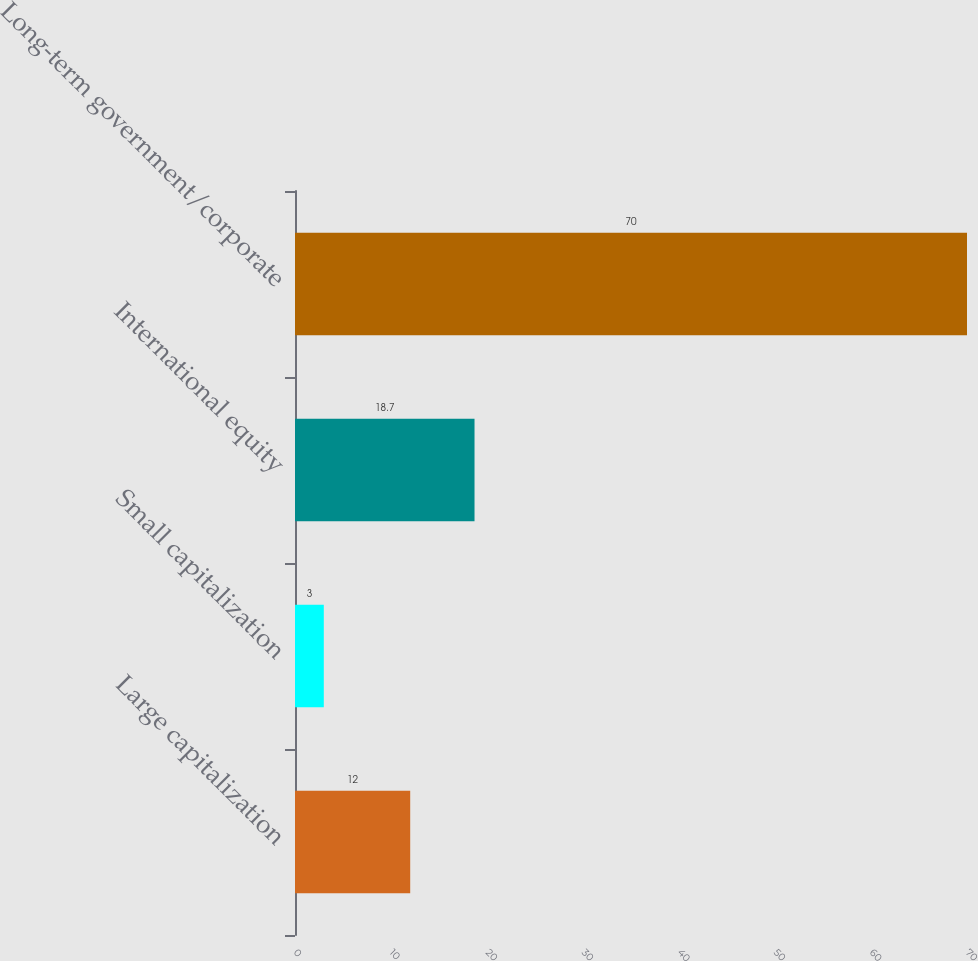Convert chart to OTSL. <chart><loc_0><loc_0><loc_500><loc_500><bar_chart><fcel>Large capitalization<fcel>Small capitalization<fcel>International equity<fcel>Long-term government/corporate<nl><fcel>12<fcel>3<fcel>18.7<fcel>70<nl></chart> 